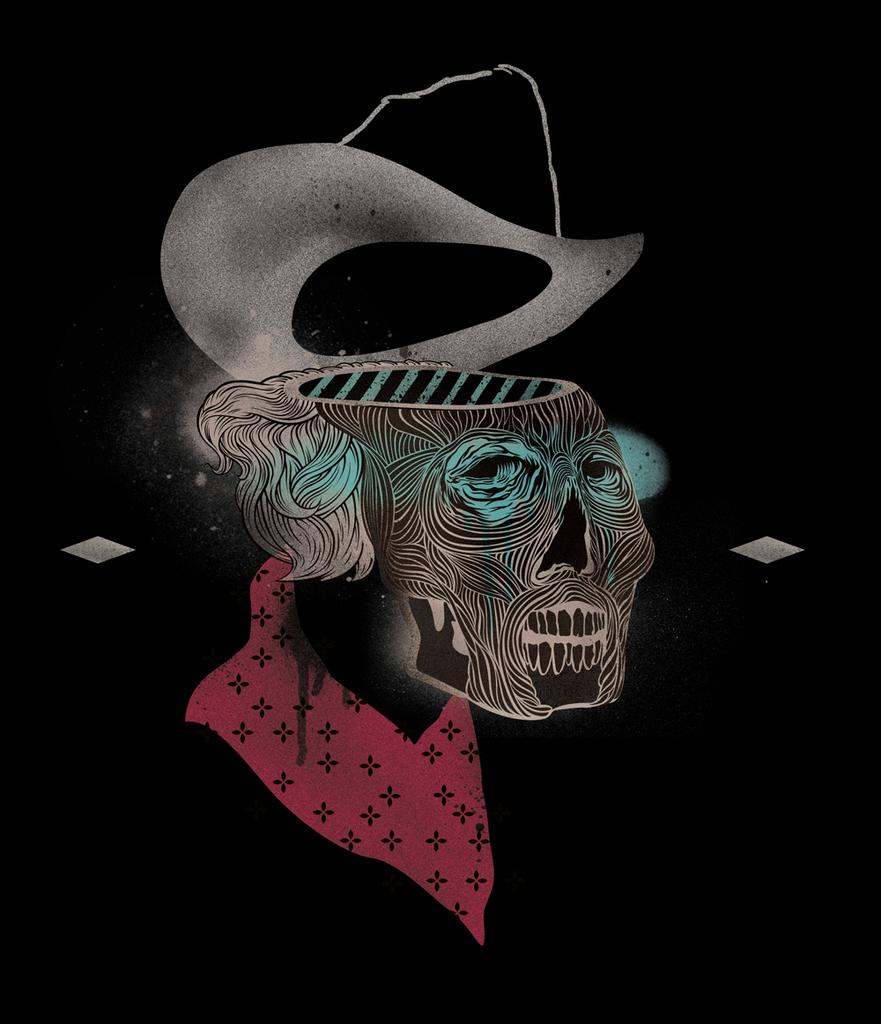What is depicted in the image? There is a drawing of a person in the image. What is the person in the drawing wearing? The person in the drawing is wearing a hat. How would you describe the overall appearance of the image? The background of the image is dark. How many trucks are parked behind the person in the drawing? There are no trucks visible in the image; it only features a drawing of a person with a hat and a dark background. 